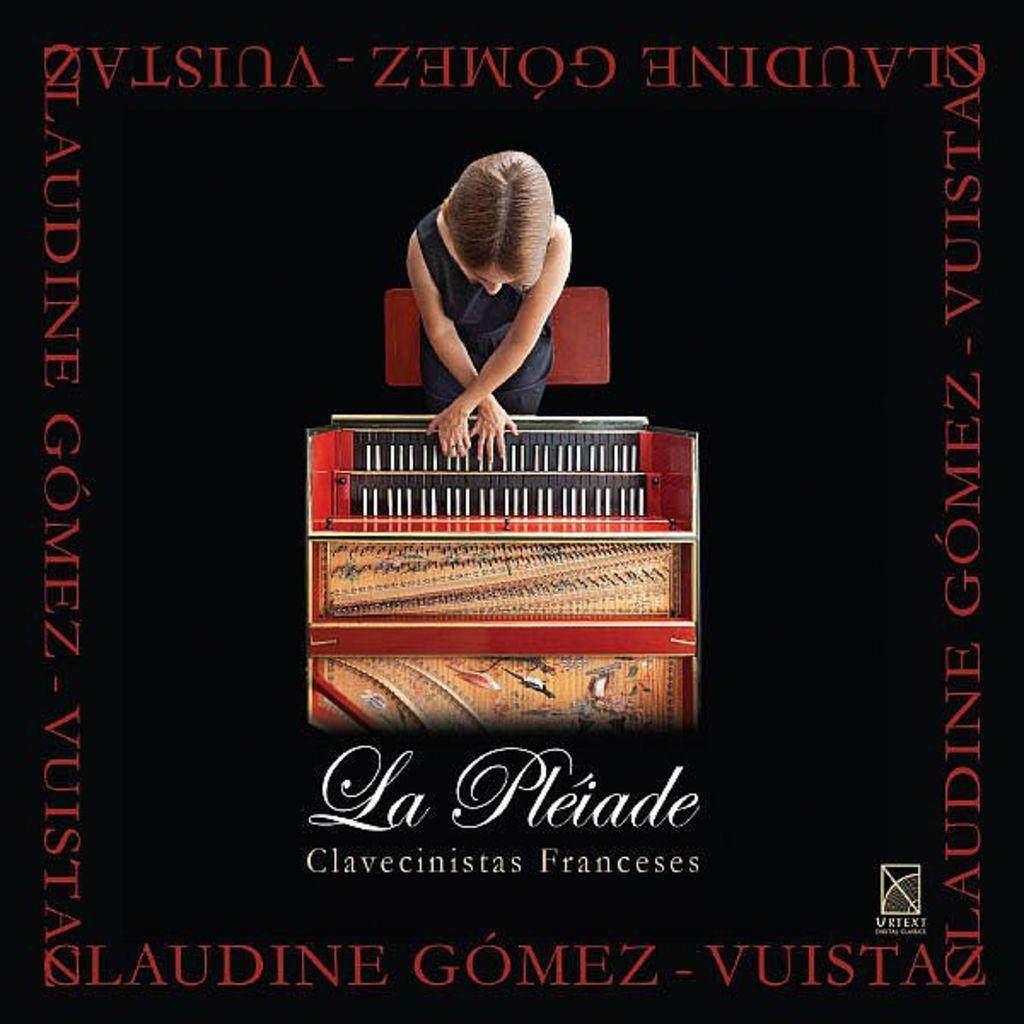Can you describe any specific editing techniques used in the image? Unfortunately, without more information about the image, it is difficult to describe any specific editing techniques used. What type of attraction can be seen in the image? There is no attraction present in the image, as it is only mentioned that the image is edited. What type of glass object is visible in the image? There is no glass object present in the image, as it is only mentioned that the image is edited. 